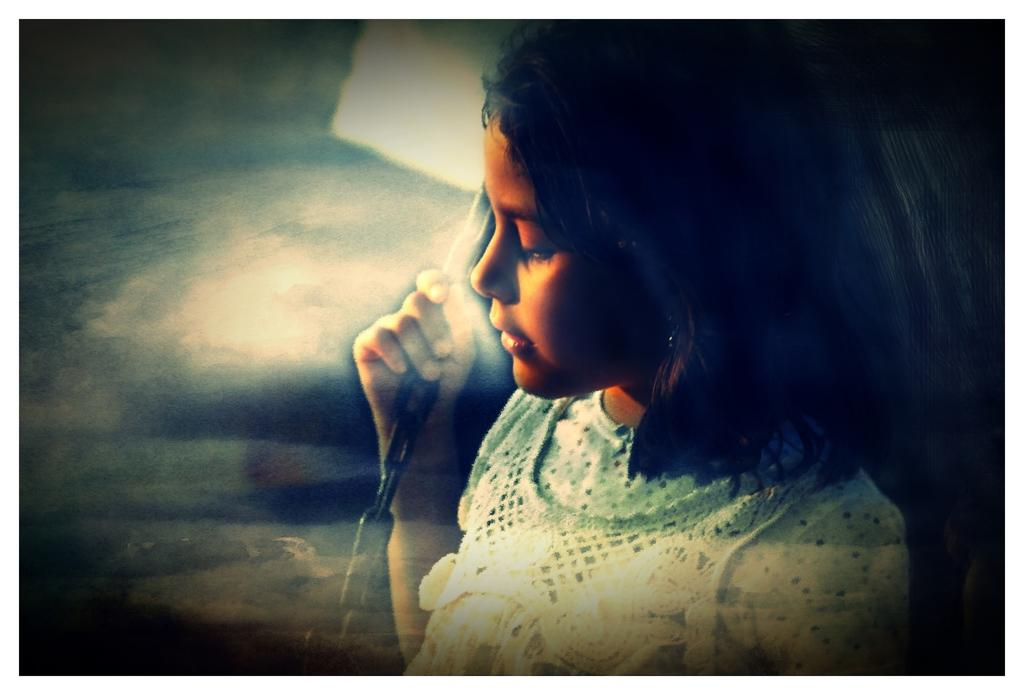What is the main subject of the image? The main subject of the image is a girl. What is the girl holding in her hand? The girl is holding a chain in her hand. Can you describe the visual quality of the left side of the image? The left side of the image is blurry. What type of rock can be seen in the image? There is no rock present in the image. What idea does the girl express by holding the chain in the image? The image does not provide any information about the girl's ideas or intentions. 